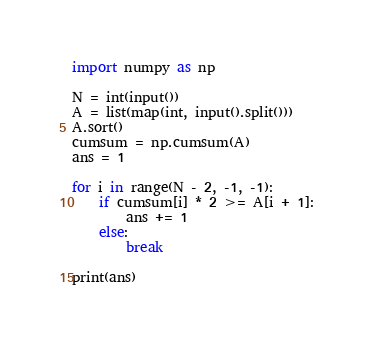Convert code to text. <code><loc_0><loc_0><loc_500><loc_500><_Python_>import numpy as np

N = int(input())
A = list(map(int, input().split()))
A.sort()
cumsum = np.cumsum(A)
ans = 1

for i in range(N - 2, -1, -1):
    if cumsum[i] * 2 >= A[i + 1]:
        ans += 1
    else:
        break

print(ans)
</code> 